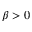Convert formula to latex. <formula><loc_0><loc_0><loc_500><loc_500>\beta > 0</formula> 